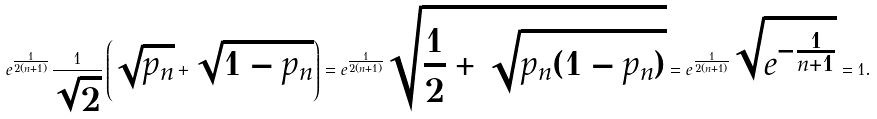Convert formula to latex. <formula><loc_0><loc_0><loc_500><loc_500>e ^ { \frac { 1 } { 2 ( n + 1 ) } } \frac { 1 } { \sqrt { 2 } } \left ( \sqrt { p _ { n } } + \sqrt { 1 - p _ { n } } \right ) = e ^ { \frac { 1 } { 2 ( n + 1 ) } } \sqrt { \frac { 1 } { 2 } + \sqrt { p _ { n } ( 1 - p _ { n } ) } } = e ^ { \frac { 1 } { 2 ( n + 1 ) } } \sqrt { e ^ { - \frac { 1 } { n + 1 } } } = 1 .</formula> 